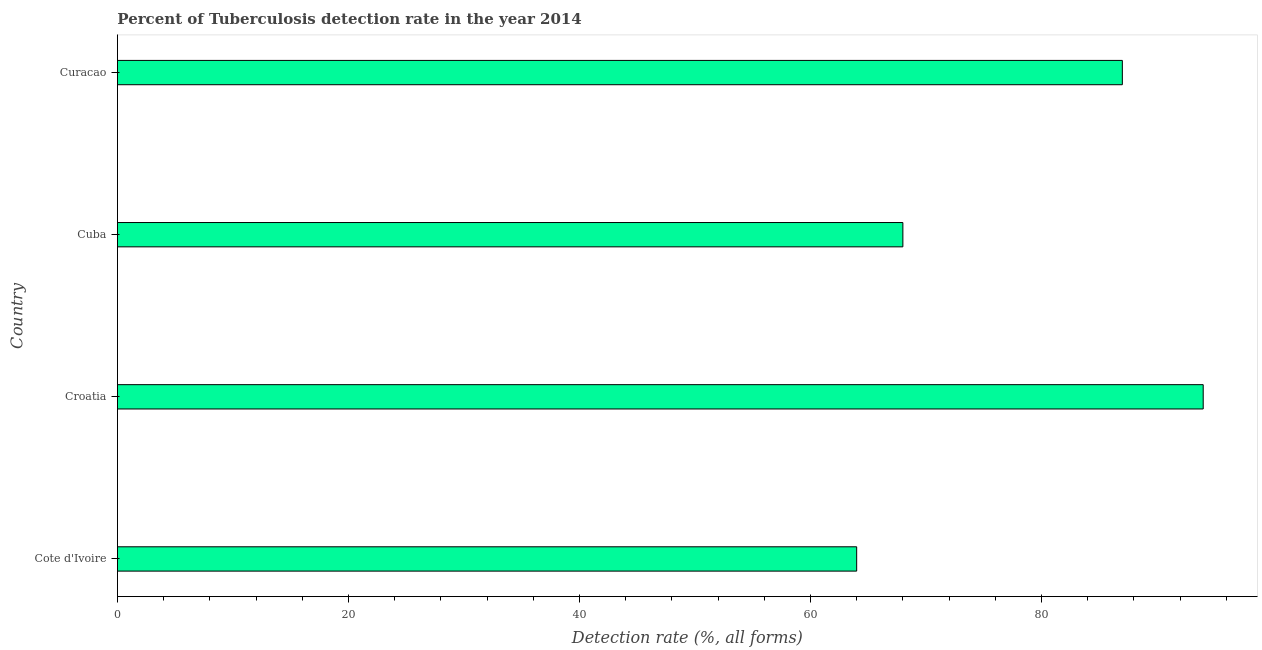Does the graph contain any zero values?
Your answer should be compact. No. Does the graph contain grids?
Offer a very short reply. No. What is the title of the graph?
Ensure brevity in your answer.  Percent of Tuberculosis detection rate in the year 2014. What is the label or title of the X-axis?
Provide a succinct answer. Detection rate (%, all forms). What is the detection rate of tuberculosis in Croatia?
Your response must be concise. 94. Across all countries, what is the maximum detection rate of tuberculosis?
Offer a very short reply. 94. Across all countries, what is the minimum detection rate of tuberculosis?
Your answer should be very brief. 64. In which country was the detection rate of tuberculosis maximum?
Your answer should be compact. Croatia. In which country was the detection rate of tuberculosis minimum?
Offer a very short reply. Cote d'Ivoire. What is the sum of the detection rate of tuberculosis?
Keep it short and to the point. 313. What is the difference between the detection rate of tuberculosis in Croatia and Cuba?
Keep it short and to the point. 26. What is the average detection rate of tuberculosis per country?
Ensure brevity in your answer.  78. What is the median detection rate of tuberculosis?
Ensure brevity in your answer.  77.5. In how many countries, is the detection rate of tuberculosis greater than 4 %?
Your answer should be very brief. 4. What is the ratio of the detection rate of tuberculosis in Cote d'Ivoire to that in Croatia?
Give a very brief answer. 0.68. Is the difference between the detection rate of tuberculosis in Cote d'Ivoire and Croatia greater than the difference between any two countries?
Make the answer very short. Yes. Is the sum of the detection rate of tuberculosis in Cuba and Curacao greater than the maximum detection rate of tuberculosis across all countries?
Provide a short and direct response. Yes. In how many countries, is the detection rate of tuberculosis greater than the average detection rate of tuberculosis taken over all countries?
Your response must be concise. 2. How many bars are there?
Your answer should be very brief. 4. Are all the bars in the graph horizontal?
Offer a very short reply. Yes. How many countries are there in the graph?
Offer a terse response. 4. What is the difference between two consecutive major ticks on the X-axis?
Your answer should be very brief. 20. Are the values on the major ticks of X-axis written in scientific E-notation?
Keep it short and to the point. No. What is the Detection rate (%, all forms) of Croatia?
Ensure brevity in your answer.  94. What is the Detection rate (%, all forms) of Cuba?
Your answer should be very brief. 68. What is the Detection rate (%, all forms) of Curacao?
Ensure brevity in your answer.  87. What is the difference between the Detection rate (%, all forms) in Croatia and Cuba?
Your answer should be very brief. 26. What is the difference between the Detection rate (%, all forms) in Cuba and Curacao?
Your answer should be compact. -19. What is the ratio of the Detection rate (%, all forms) in Cote d'Ivoire to that in Croatia?
Ensure brevity in your answer.  0.68. What is the ratio of the Detection rate (%, all forms) in Cote d'Ivoire to that in Cuba?
Your answer should be compact. 0.94. What is the ratio of the Detection rate (%, all forms) in Cote d'Ivoire to that in Curacao?
Keep it short and to the point. 0.74. What is the ratio of the Detection rate (%, all forms) in Croatia to that in Cuba?
Offer a terse response. 1.38. What is the ratio of the Detection rate (%, all forms) in Croatia to that in Curacao?
Offer a terse response. 1.08. What is the ratio of the Detection rate (%, all forms) in Cuba to that in Curacao?
Your answer should be compact. 0.78. 